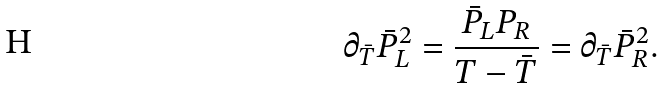Convert formula to latex. <formula><loc_0><loc_0><loc_500><loc_500>\partial _ { \bar { T } } { \bar { P } } _ { L } ^ { 2 } = \frac { { \bar { P } } _ { L } P _ { R } } { T - { \bar { T } } } = \partial _ { \bar { T } } { \bar { P } } _ { R } ^ { 2 } .</formula> 